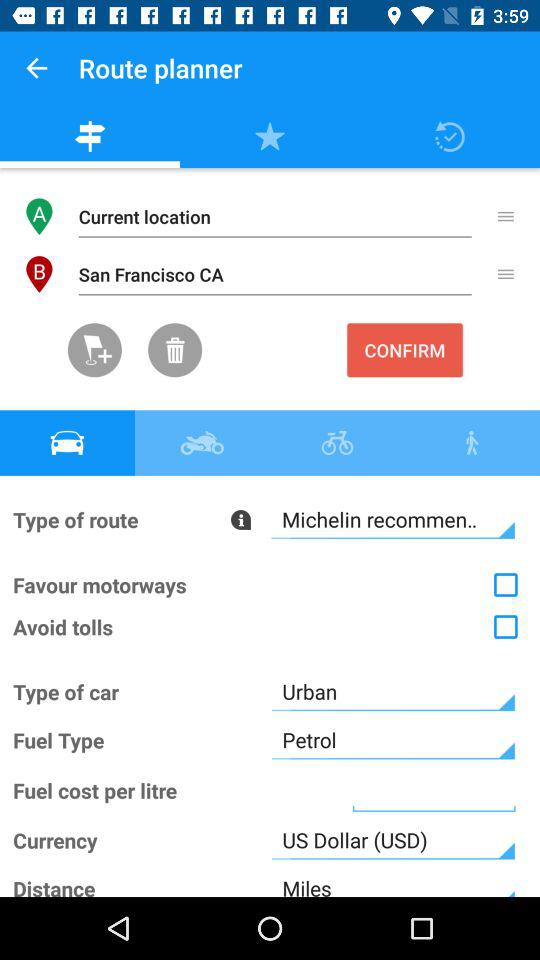What is the car type? The car type is "Urban". 